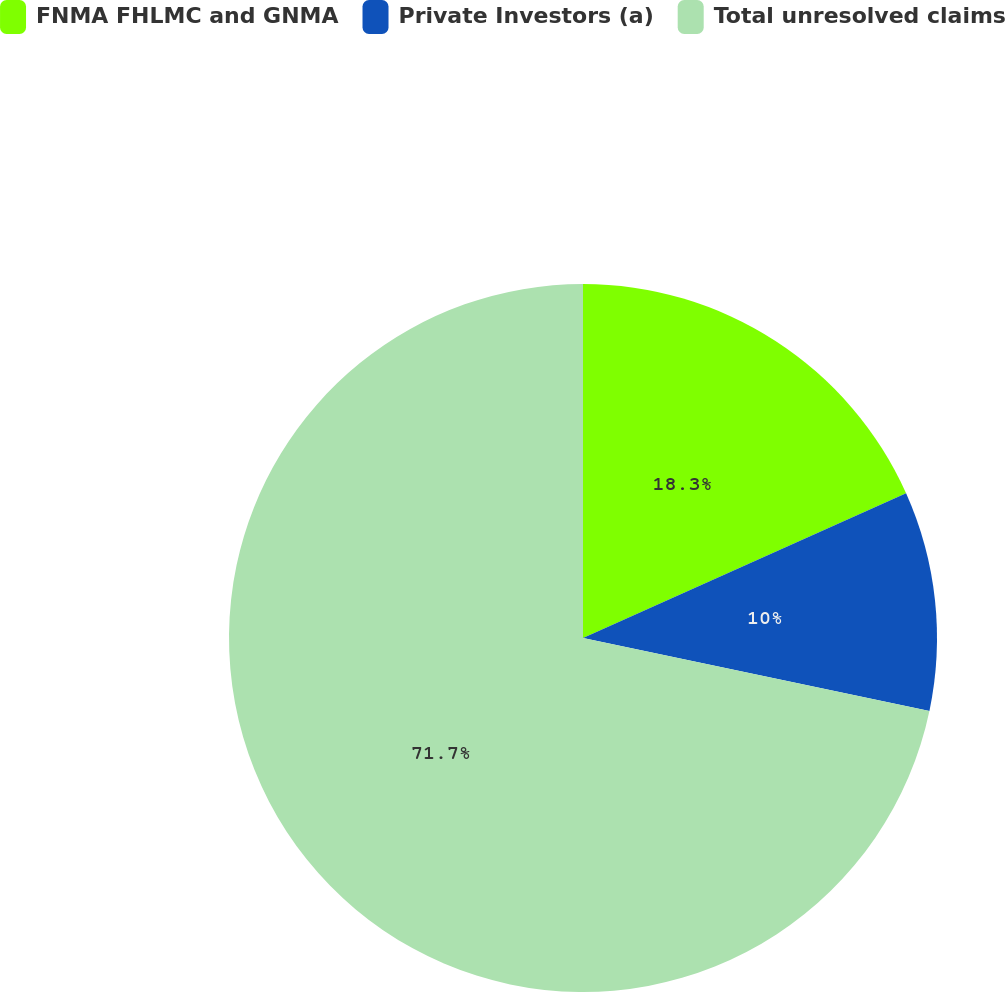Convert chart to OTSL. <chart><loc_0><loc_0><loc_500><loc_500><pie_chart><fcel>FNMA FHLMC and GNMA<fcel>Private Investors (a)<fcel>Total unresolved claims<nl><fcel>18.3%<fcel>10.0%<fcel>71.7%<nl></chart> 